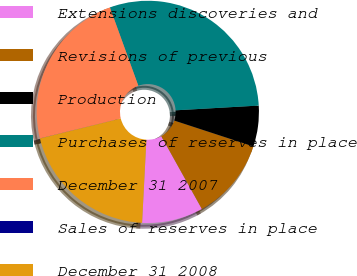Convert chart to OTSL. <chart><loc_0><loc_0><loc_500><loc_500><pie_chart><fcel>Extensions discoveries and<fcel>Revisions of previous<fcel>Production<fcel>Purchases of reserves in place<fcel>December 31 2007<fcel>Sales of reserves in place<fcel>December 31 2008<nl><fcel>8.91%<fcel>11.88%<fcel>5.94%<fcel>29.63%<fcel>23.3%<fcel>0.01%<fcel>20.33%<nl></chart> 